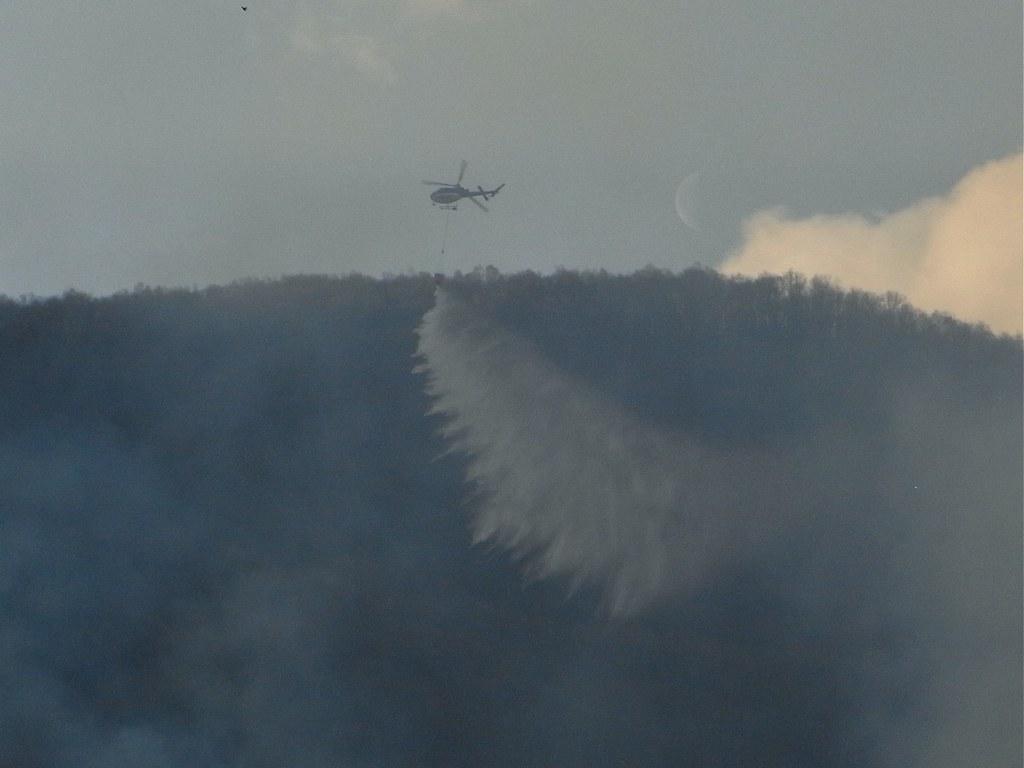How would you summarize this image in a sentence or two? In this image, in the middle, we can see a helicopter which is in the air. In the background, we can see a sky which is a bit cloudy, at the bottom, we can see black color and some smoke. 